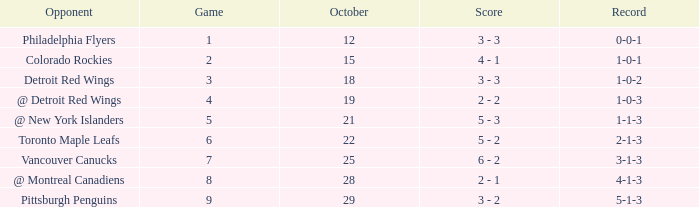Name the score for game more than 6 and before october 28 6 - 2. Can you give me this table as a dict? {'header': ['Opponent', 'Game', 'October', 'Score', 'Record'], 'rows': [['Philadelphia Flyers', '1', '12', '3 - 3', '0-0-1'], ['Colorado Rockies', '2', '15', '4 - 1', '1-0-1'], ['Detroit Red Wings', '3', '18', '3 - 3', '1-0-2'], ['@ Detroit Red Wings', '4', '19', '2 - 2', '1-0-3'], ['@ New York Islanders', '5', '21', '5 - 3', '1-1-3'], ['Toronto Maple Leafs', '6', '22', '5 - 2', '2-1-3'], ['Vancouver Canucks', '7', '25', '6 - 2', '3-1-3'], ['@ Montreal Canadiens', '8', '28', '2 - 1', '4-1-3'], ['Pittsburgh Penguins', '9', '29', '3 - 2', '5-1-3']]} 